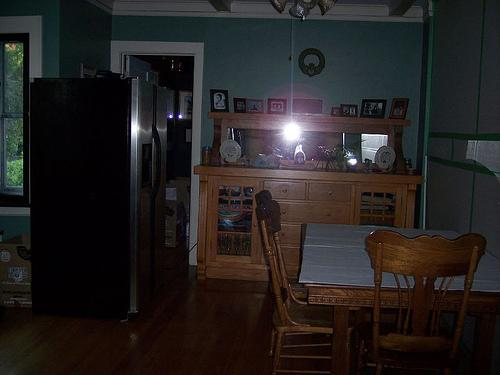What is the large silver object to the left used to store? Please explain your reasoning. food. It is a fridge. 